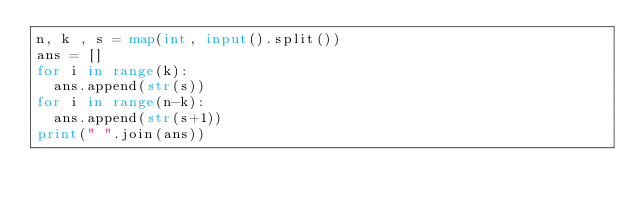Convert code to text. <code><loc_0><loc_0><loc_500><loc_500><_Python_>n, k , s = map(int, input().split())
ans = []
for i in range(k):
  ans.append(str(s))
for i in range(n-k):
  ans.append(str(s+1))
print(" ".join(ans))</code> 